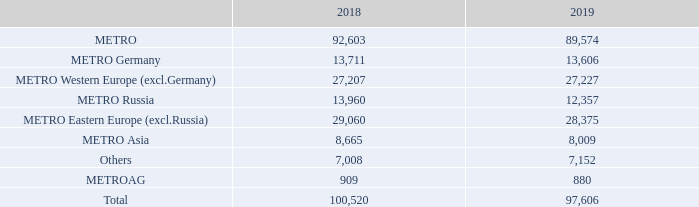DEVELOPMENT OF EMPLOYEE NUMBERS BY SEGMENTS
By headcount1 as of closing date of 30/9
1 Excluding METRO China.
When are the employee numbers by segments counted? As of closing date of 30/9. What is excluded in the headcount as of closing date of 30/9? Metro china. What are the different segments under METRO when accounting for the employee numbers by segments? Metro germany, metro western europe (excl.germany), metro russia, metro eastern europe (excl.russia), metro asia. In which year was the amount in METRO Asia headcount larger? 8,665>8,009
Answer: 2018. What was the change in METRO AG headcount in 2019 from 2018? 880-909
Answer: -29. What was the percentage change in METRO AG headcount in 2019 from 2018?
Answer scale should be: percent. (880-909)/909
Answer: -3.19. 